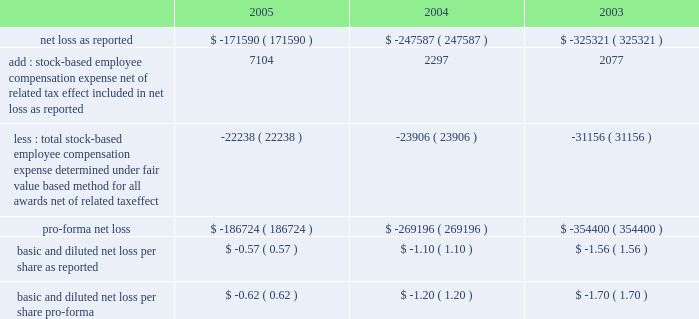American tower corporation and subsidiaries notes to consolidated financial statements 2014 ( continued ) sfas no .
148 .
In accordance with apb no .
25 , the company recognizes compensation expense based on the excess , if any , of the quoted stock price at the grant date of the award or other measurement date over the amount an employee must pay to acquire the stock .
The company 2019s stock option plans are more fully described in note 14 .
In december 2004 , the fasb issued sfas no .
123 ( revised 2004 ) , 201cshare-based payment 201d ( sfas 123r ) , as further described below .
During the year ended december 31 , 2005 , the company reevaluated the assumptions used to estimate the fair value of stock options issued to employees .
As a result , the company lowered its expected volatility assumption for options granted after july 1 , 2005 to approximately 30% ( 30 % ) and increased the expected life of option grants to 6.25 years using the simplified method permitted by sec sab no .
107 , 201dshare-based payment 201d ( sab no .
107 ) .
The company made this change based on a number of factors , including the company 2019s execution of its strategic plans to sell non-core businesses , reduce leverage and refinance its debt , and its recent merger with spectrasite , inc .
( see note 2. ) management had previously based its volatility assumptions on historical volatility since inception , which included periods when the company 2019s capital structure was more highly leveraged than current levels and expected levels for the foreseeable future .
Management 2019s estimate of future volatility is based on its consideration of all available information , including historical volatility , implied volatility of publicly traded options , the company 2019s current capital structure and its publicly announced future business plans .
For comparative purposes , a 10% ( 10 % ) change in the volatility assumption would change pro forma stock option expense and pro forma net loss by approximately $ 0.1 million for the year ended december 31 , 2005 .
( see note 14. ) the table illustrates the effect on net loss and net loss per common share if the company had applied the fair value recognition provisions of sfas no .
123 ( as amended ) to stock-based compensation .
The estimated fair value of each option is calculated using the black-scholes option-pricing model ( in thousands , except per share amounts ) : .
The company has modified certain option awards to revise vesting and exercise terms for certain terminated employees and recognized charges of $ 7.0 million , $ 3.0 million and $ 2.3 million for the years ended december 31 , 2005 , 2004 and 2003 , respectively .
In addition , the stock-based employee compensation amounts above for the year ended december 31 , 2005 , include approximately $ 2.4 million of unearned compensation amortization related to unvested stock options assumed in the merger with spectrasite , inc .
Such charges are reflected in impairments , net loss on sale of long-lived assets , restructuring and merger related expense with corresponding adjustments to additional paid-in capital and unearned compensation in the accompanying consolidated financial statements .
Recent accounting pronouncements 2014in december 2004 , the fasb issued sfas 123r , which supersedes apb no .
25 , and amends sfas no .
95 , 201cstatement of cash flows . 201d this statement addressed the accounting for share-based payments to employees , including grants of employee stock options .
Under the new standard .
What is the total number of outstanding shares as of december 31 , 2004 according to pro-forma income , in millions? 
Computations: (((269196 * 1000) / 1.20) / 1000000)
Answer: 224.33. 